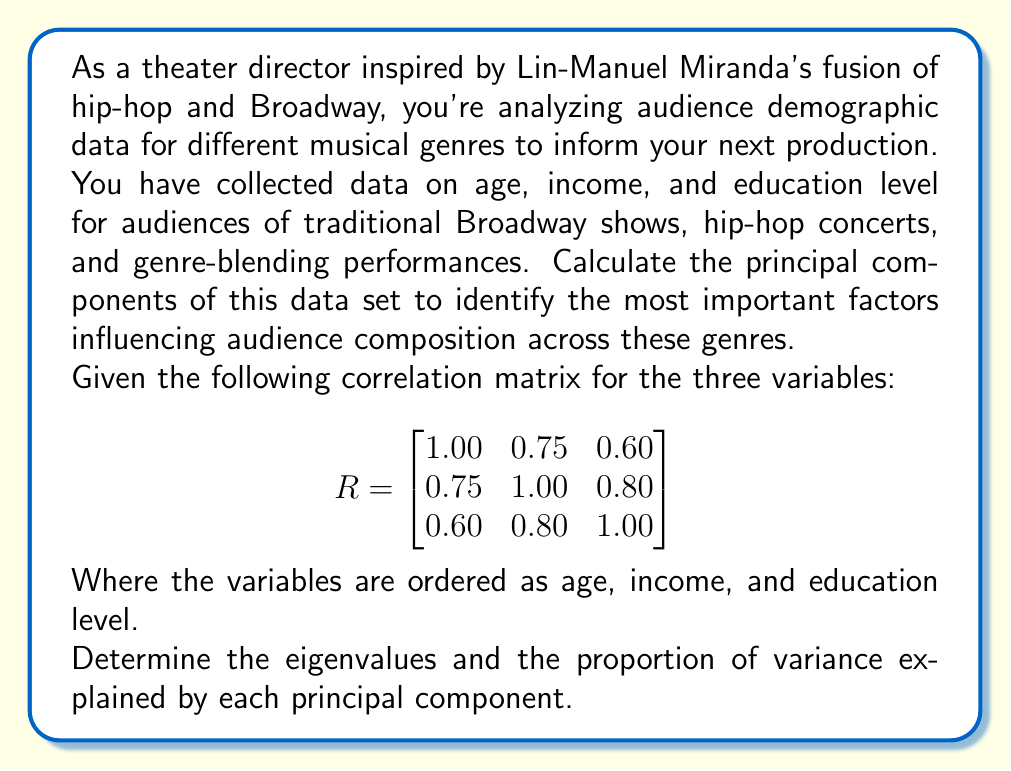Can you answer this question? To calculate the principal components, we need to follow these steps:

1. Start with the correlation matrix $R$.

2. Calculate the eigenvalues of $R$ by solving the characteristic equation:
   $det(R - \lambda I) = 0$

   $$
   \begin{vmatrix}
   1.00 - \lambda & 0.75 & 0.60 \\
   0.75 & 1.00 - \lambda & 0.80 \\
   0.60 & 0.80 & 1.00 - \lambda
   \end{vmatrix} = 0
   $$

3. Expanding this determinant gives us the cubic equation:
   $-\lambda^3 + 3\lambda^2 - 0.715\lambda - 0.5375 = 0$

4. Solving this equation (using a calculator or computer algebra system) yields the eigenvalues:
   $\lambda_1 \approx 2.5403$
   $\lambda_2 \approx 0.3561$
   $\lambda_3 \approx 0.1036$

5. The proportion of variance explained by each principal component is calculated by dividing each eigenvalue by the sum of all eigenvalues:

   Total variance = $2.5403 + 0.3561 + 0.1036 = 3$

   For PC1: $2.5403 / 3 \approx 0.8468$ or 84.68%
   For PC2: $0.3561 / 3 \approx 0.1187$ or 11.87%
   For PC3: $0.1036 / 3 \approx 0.0345$ or 3.45%

These results show that the first principal component explains about 84.68% of the variance in the data, which is a significant amount. This suggests that there is a strong common factor influencing age, income, and education level across different musical genre audiences.
Answer: Eigenvalues: $\lambda_1 \approx 2.5403$, $\lambda_2 \approx 0.3561$, $\lambda_3 \approx 0.1036$

Proportion of variance explained:
PC1: 84.68%
PC2: 11.87%
PC3: 3.45% 